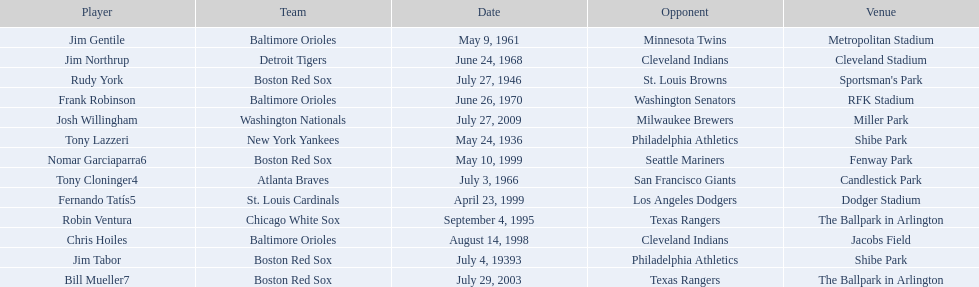What were the dates of each game? May 24, 1936, July 4, 19393, July 27, 1946, May 9, 1961, July 3, 1966, June 24, 1968, June 26, 1970, September 4, 1995, August 14, 1998, April 23, 1999, May 10, 1999, July 29, 2003, July 27, 2009. Who were all of the teams? New York Yankees, Boston Red Sox, Boston Red Sox, Baltimore Orioles, Atlanta Braves, Detroit Tigers, Baltimore Orioles, Chicago White Sox, Baltimore Orioles, St. Louis Cardinals, Boston Red Sox, Boston Red Sox, Washington Nationals. What about their opponents? Philadelphia Athletics, Philadelphia Athletics, St. Louis Browns, Minnesota Twins, San Francisco Giants, Cleveland Indians, Washington Senators, Texas Rangers, Cleveland Indians, Los Angeles Dodgers, Seattle Mariners, Texas Rangers, Milwaukee Brewers. And on which date did the detroit tigers play against the cleveland indians? June 24, 1968. 